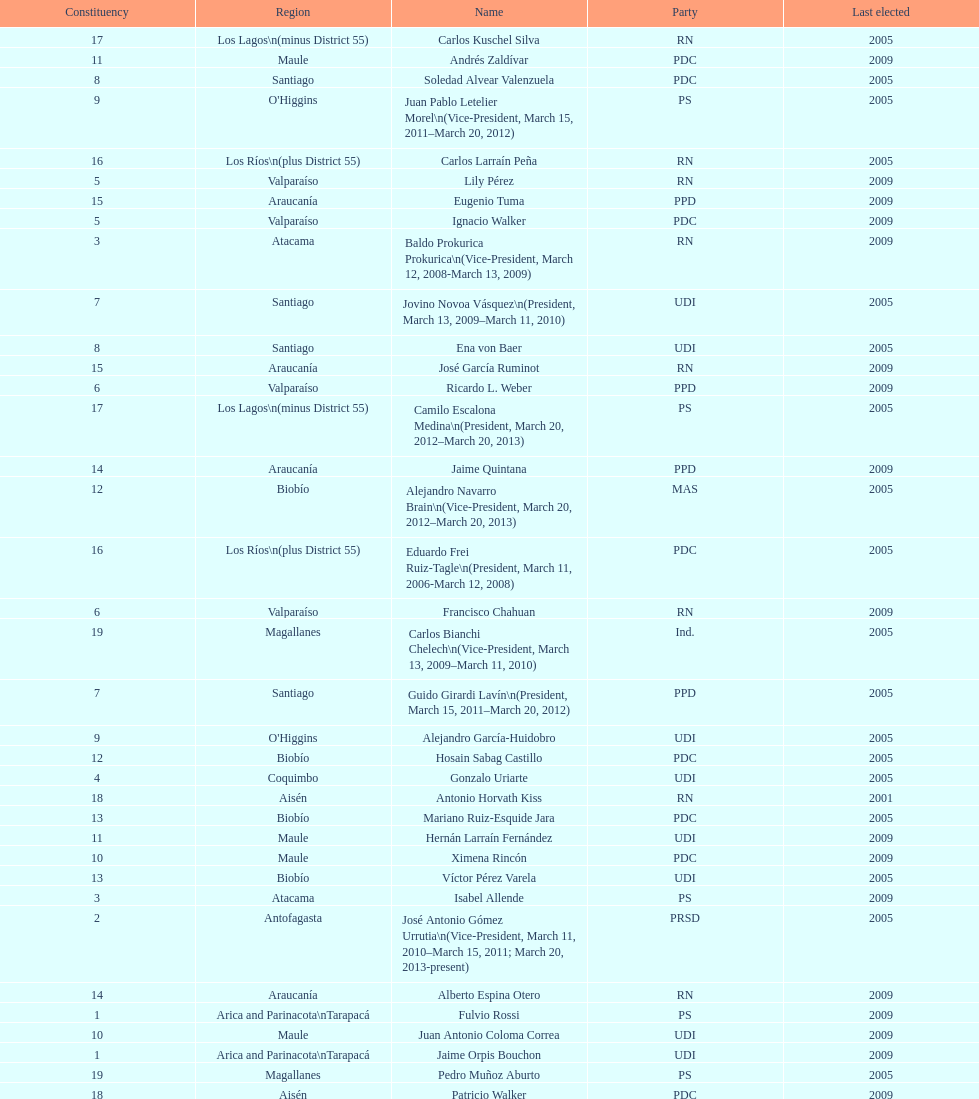Which party did jaime quintana belong to? PPD. Can you give me this table as a dict? {'header': ['Constituency', 'Region', 'Name', 'Party', 'Last elected'], 'rows': [['17', 'Los Lagos\\n(minus District 55)', 'Carlos Kuschel Silva', 'RN', '2005'], ['11', 'Maule', 'Andrés Zaldívar', 'PDC', '2009'], ['8', 'Santiago', 'Soledad Alvear Valenzuela', 'PDC', '2005'], ['9', "O'Higgins", 'Juan Pablo Letelier Morel\\n(Vice-President, March 15, 2011–March 20, 2012)', 'PS', '2005'], ['16', 'Los Ríos\\n(plus District 55)', 'Carlos Larraín Peña', 'RN', '2005'], ['5', 'Valparaíso', 'Lily Pérez', 'RN', '2009'], ['15', 'Araucanía', 'Eugenio Tuma', 'PPD', '2009'], ['5', 'Valparaíso', 'Ignacio Walker', 'PDC', '2009'], ['3', 'Atacama', 'Baldo Prokurica Prokurica\\n(Vice-President, March 12, 2008-March 13, 2009)', 'RN', '2009'], ['7', 'Santiago', 'Jovino Novoa Vásquez\\n(President, March 13, 2009–March 11, 2010)', 'UDI', '2005'], ['8', 'Santiago', 'Ena von Baer', 'UDI', '2005'], ['15', 'Araucanía', 'José García Ruminot', 'RN', '2009'], ['6', 'Valparaíso', 'Ricardo L. Weber', 'PPD', '2009'], ['17', 'Los Lagos\\n(minus District 55)', 'Camilo Escalona Medina\\n(President, March 20, 2012–March 20, 2013)', 'PS', '2005'], ['14', 'Araucanía', 'Jaime Quintana', 'PPD', '2009'], ['12', 'Biobío', 'Alejandro Navarro Brain\\n(Vice-President, March 20, 2012–March 20, 2013)', 'MAS', '2005'], ['16', 'Los Ríos\\n(plus District 55)', 'Eduardo Frei Ruiz-Tagle\\n(President, March 11, 2006-March 12, 2008)', 'PDC', '2005'], ['6', 'Valparaíso', 'Francisco Chahuan', 'RN', '2009'], ['19', 'Magallanes', 'Carlos Bianchi Chelech\\n(Vice-President, March 13, 2009–March 11, 2010)', 'Ind.', '2005'], ['7', 'Santiago', 'Guido Girardi Lavín\\n(President, March 15, 2011–March 20, 2012)', 'PPD', '2005'], ['9', "O'Higgins", 'Alejandro García-Huidobro', 'UDI', '2005'], ['12', 'Biobío', 'Hosain Sabag Castillo', 'PDC', '2005'], ['4', 'Coquimbo', 'Gonzalo Uriarte', 'UDI', '2005'], ['18', 'Aisén', 'Antonio Horvath Kiss', 'RN', '2001'], ['13', 'Biobío', 'Mariano Ruiz-Esquide Jara', 'PDC', '2005'], ['11', 'Maule', 'Hernán Larraín Fernández', 'UDI', '2009'], ['10', 'Maule', 'Ximena Rincón', 'PDC', '2009'], ['13', 'Biobío', 'Víctor Pérez Varela', 'UDI', '2005'], ['3', 'Atacama', 'Isabel Allende', 'PS', '2009'], ['2', 'Antofagasta', 'José Antonio Gómez Urrutia\\n(Vice-President, March 11, 2010–March 15, 2011; March 20, 2013-present)', 'PRSD', '2005'], ['14', 'Araucanía', 'Alberto Espina Otero', 'RN', '2009'], ['1', 'Arica and Parinacota\\nTarapacá', 'Fulvio Rossi', 'PS', '2009'], ['10', 'Maule', 'Juan Antonio Coloma Correa', 'UDI', '2009'], ['1', 'Arica and Parinacota\\nTarapacá', 'Jaime Orpis Bouchon', 'UDI', '2009'], ['19', 'Magallanes', 'Pedro Muñoz Aburto', 'PS', '2005'], ['18', 'Aisén', 'Patricio Walker', 'PDC', '2009'], ['4', 'Coquimbo', 'Jorge Pizarro Soto\\n(President, March 11, 2010–March 15, 2011; March 20, 2013-present)', 'PDC', '2005'], ['2', 'Antofagasta', 'Carlos Cantero Ojeda', 'Ind.', '2005']]} 